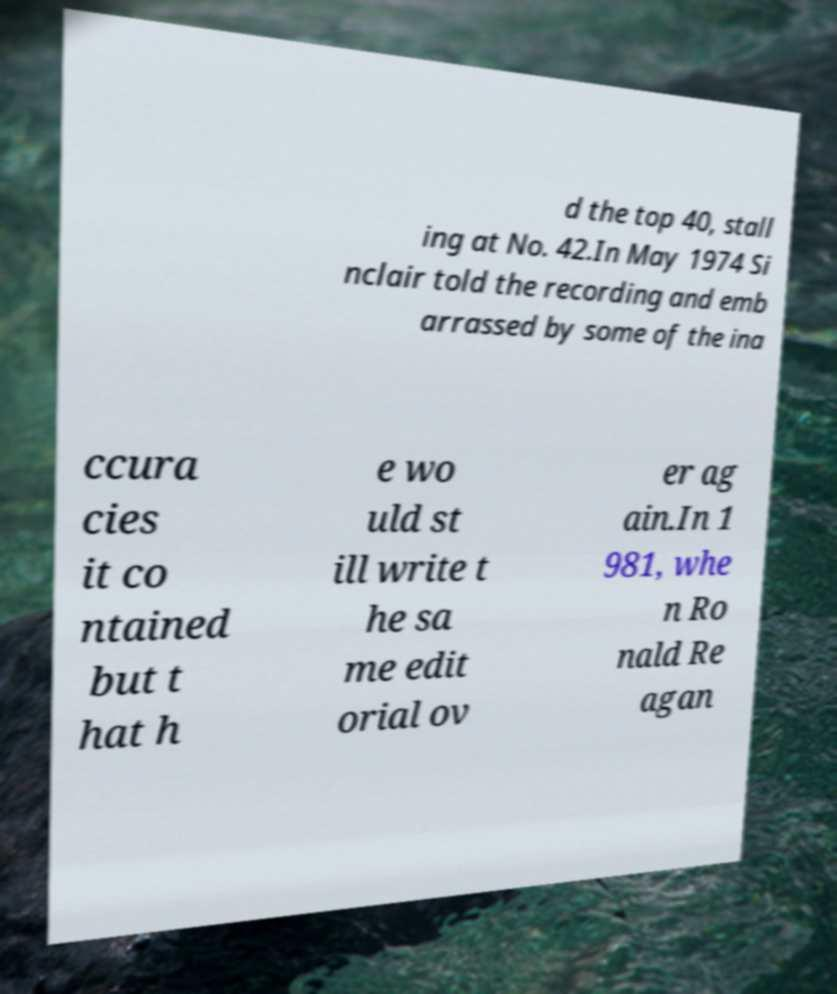For documentation purposes, I need the text within this image transcribed. Could you provide that? d the top 40, stall ing at No. 42.In May 1974 Si nclair told the recording and emb arrassed by some of the ina ccura cies it co ntained but t hat h e wo uld st ill write t he sa me edit orial ov er ag ain.In 1 981, whe n Ro nald Re agan 